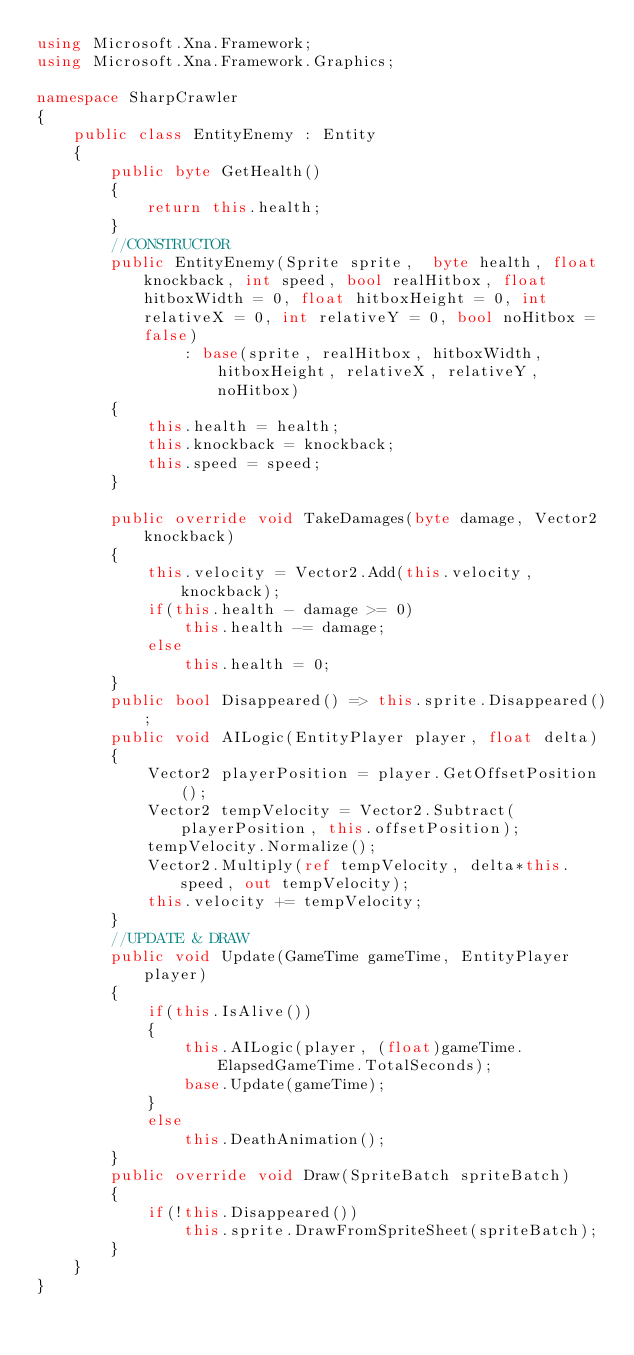Convert code to text. <code><loc_0><loc_0><loc_500><loc_500><_C#_>using Microsoft.Xna.Framework;
using Microsoft.Xna.Framework.Graphics;

namespace SharpCrawler
{
    public class EntityEnemy : Entity
    {
        public byte GetHealth()
        {
            return this.health;
        }
        //CONSTRUCTOR
        public EntityEnemy(Sprite sprite,  byte health, float knockback, int speed, bool realHitbox, float hitboxWidth = 0, float hitboxHeight = 0, int relativeX = 0, int relativeY = 0, bool noHitbox = false)
                : base(sprite, realHitbox, hitboxWidth, hitboxHeight, relativeX, relativeY, noHitbox)
        {
            this.health = health;
            this.knockback = knockback;
            this.speed = speed;
        }
        
        public override void TakeDamages(byte damage, Vector2 knockback)
        {
            this.velocity = Vector2.Add(this.velocity, knockback);
            if(this.health - damage >= 0)
                this.health -= damage;
            else
                this.health = 0;
        }
        public bool Disappeared() => this.sprite.Disappeared();
        public void AILogic(EntityPlayer player, float delta)
        {
            Vector2 playerPosition = player.GetOffsetPosition();
            Vector2 tempVelocity = Vector2.Subtract(playerPosition, this.offsetPosition);
            tempVelocity.Normalize();
            Vector2.Multiply(ref tempVelocity, delta*this.speed, out tempVelocity);
            this.velocity += tempVelocity;
        }
        //UPDATE & DRAW
        public void Update(GameTime gameTime, EntityPlayer player)
        {
            if(this.IsAlive())
            {
                this.AILogic(player, (float)gameTime.ElapsedGameTime.TotalSeconds);
                base.Update(gameTime);
            }
            else
                this.DeathAnimation();
        }
        public override void Draw(SpriteBatch spriteBatch)
        {
            if(!this.Disappeared())
                this.sprite.DrawFromSpriteSheet(spriteBatch);
        }
    }
}</code> 